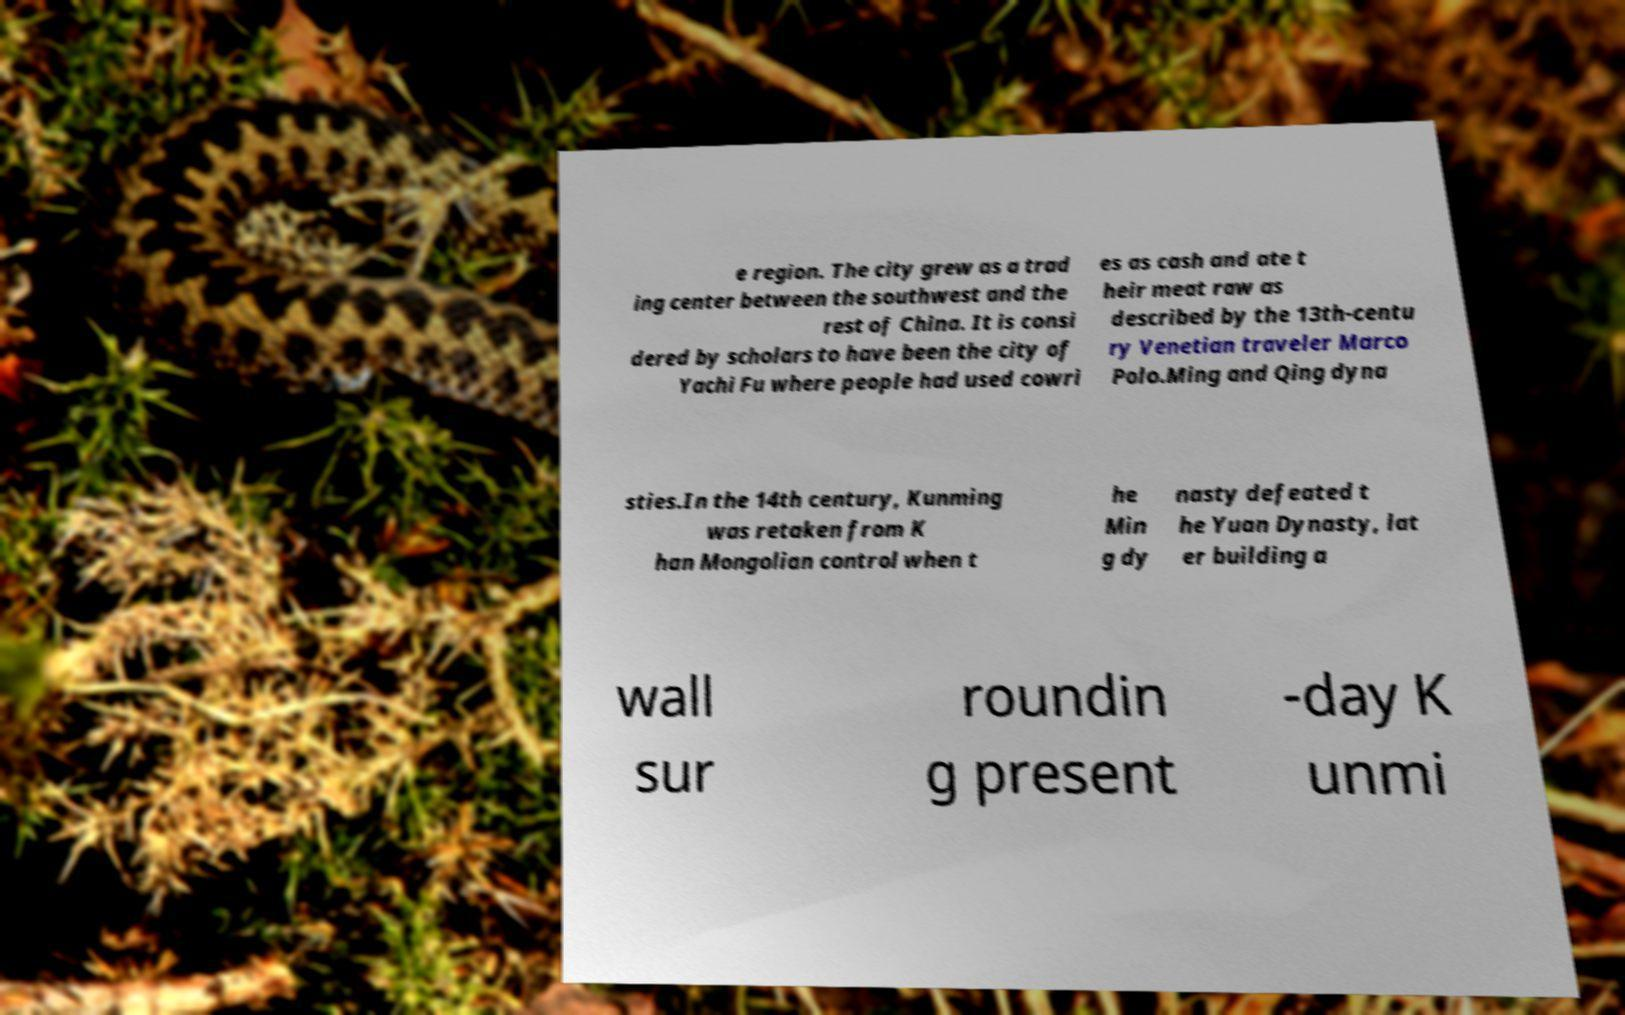Please identify and transcribe the text found in this image. e region. The city grew as a trad ing center between the southwest and the rest of China. It is consi dered by scholars to have been the city of Yachi Fu where people had used cowri es as cash and ate t heir meat raw as described by the 13th-centu ry Venetian traveler Marco Polo.Ming and Qing dyna sties.In the 14th century, Kunming was retaken from K han Mongolian control when t he Min g dy nasty defeated t he Yuan Dynasty, lat er building a wall sur roundin g present -day K unmi 